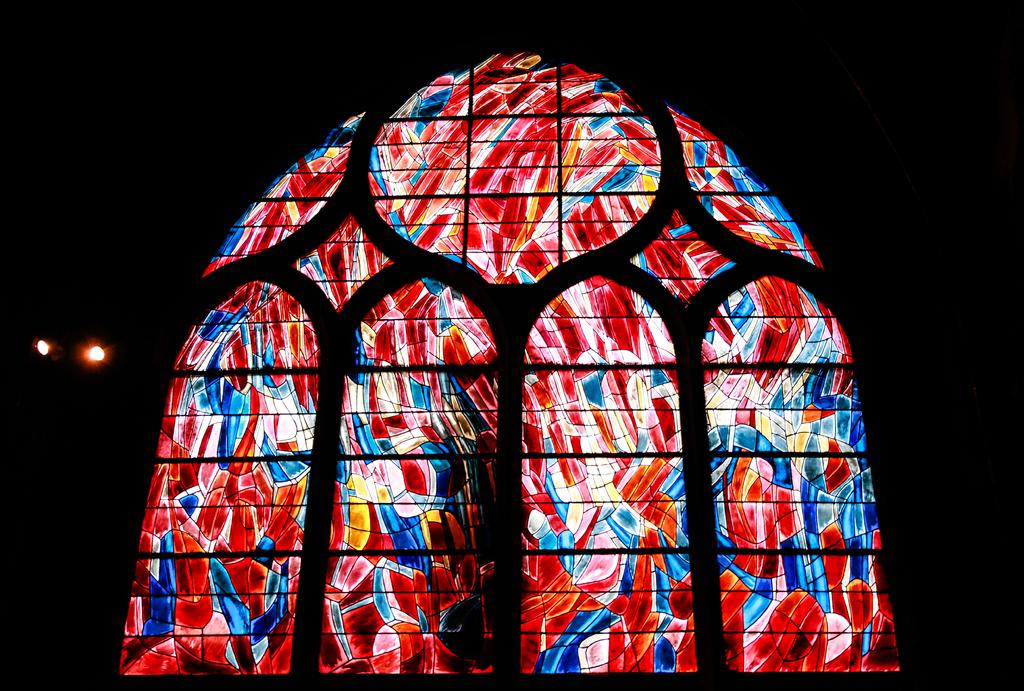What type of artwork is featured in the image? The image contains a glass painting. What color is the background of the image? The background of the image is black in color. Can you see any blood on the glass painting in the image? There is no blood visible on the glass painting in the image. How many toes are visible on the glass painting in the image? There are no toes depicted on the glass painting in the image. 